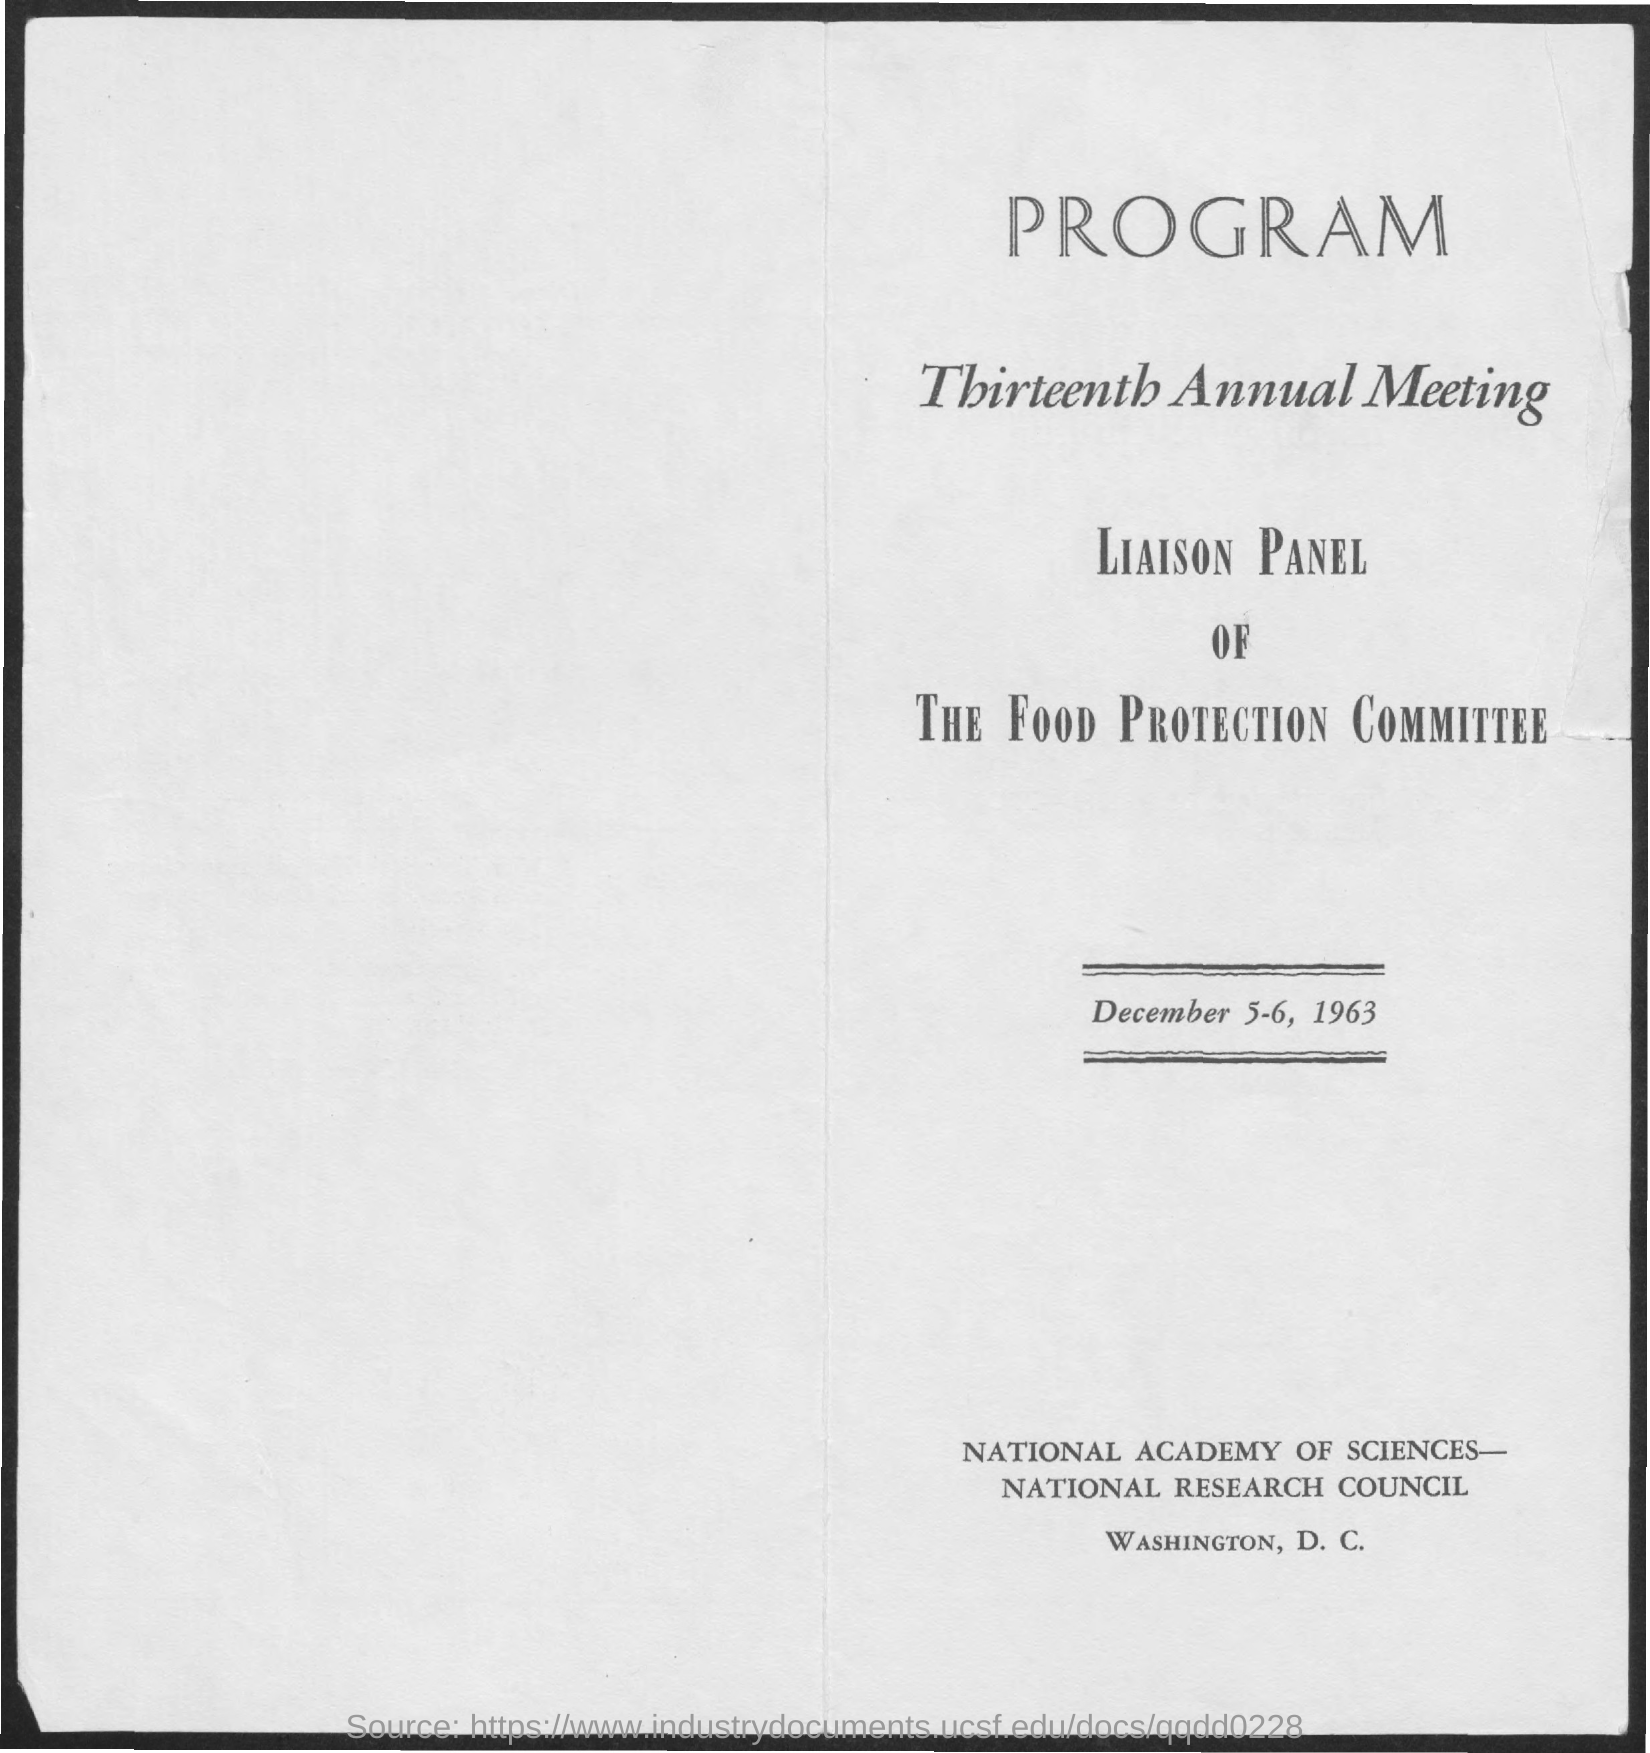List a handful of essential elements in this visual. The second title in the document is "Thirteenth Annual Meeting. 